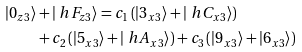<formula> <loc_0><loc_0><loc_500><loc_500>\left | 0 _ { z 3 } \right \rangle & + \left | \ h F _ { z 3 } \right \rangle = c _ { 1 } \left ( \left | 3 _ { x 3 } \right \rangle + \left | \ h C _ { x 3 } \right \rangle \right ) \\ & + c _ { 2 } \left ( \left | 5 _ { x 3 } \right \rangle + \left | \ h A _ { x 3 } \right \rangle \right ) + c _ { 3 } \left ( \left | 9 _ { x 3 } \right \rangle + \left | 6 _ { x 3 } \right \rangle \right )</formula> 